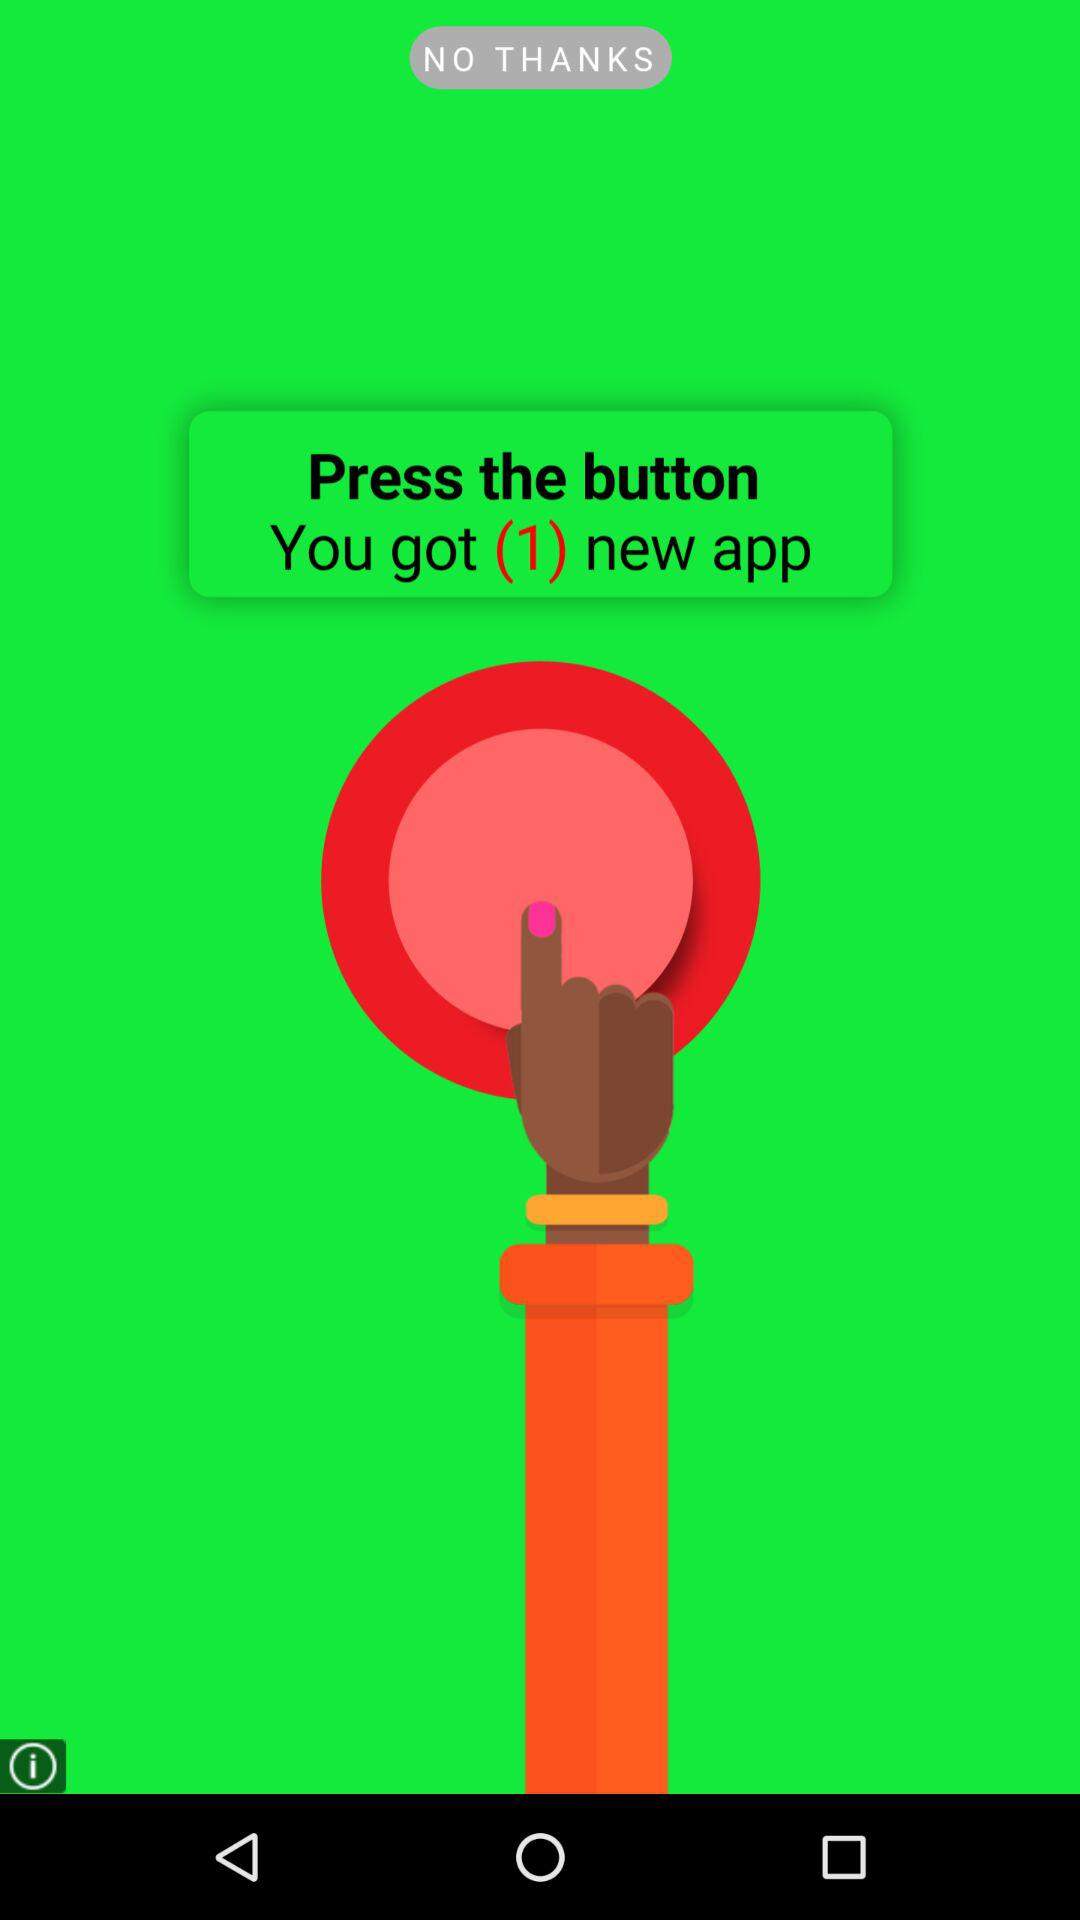How many new apps do I have?
Answer the question using a single word or phrase. 1 